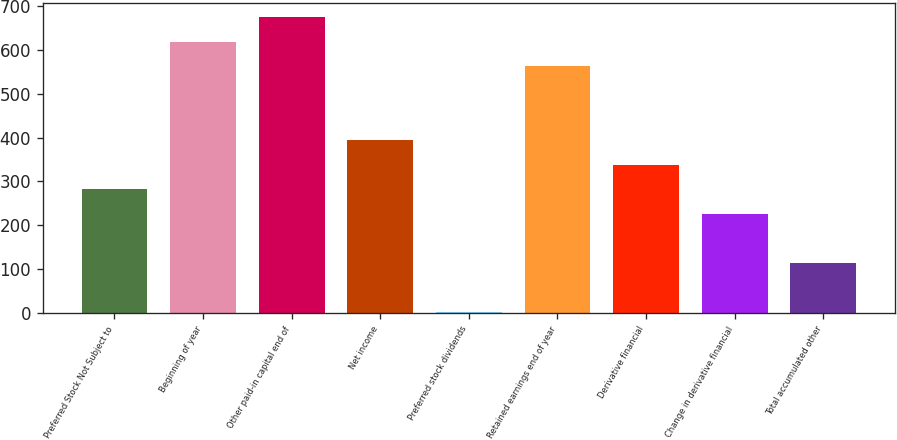<chart> <loc_0><loc_0><loc_500><loc_500><bar_chart><fcel>Preferred Stock Not Subject to<fcel>Beginning of year<fcel>Other paid-in capital end of<fcel>Net income<fcel>Preferred stock dividends<fcel>Retained earnings end of year<fcel>Derivative financial<fcel>Change in derivative financial<fcel>Total accumulated other<nl><fcel>282<fcel>618<fcel>674<fcel>394<fcel>2<fcel>562<fcel>338<fcel>226<fcel>114<nl></chart> 